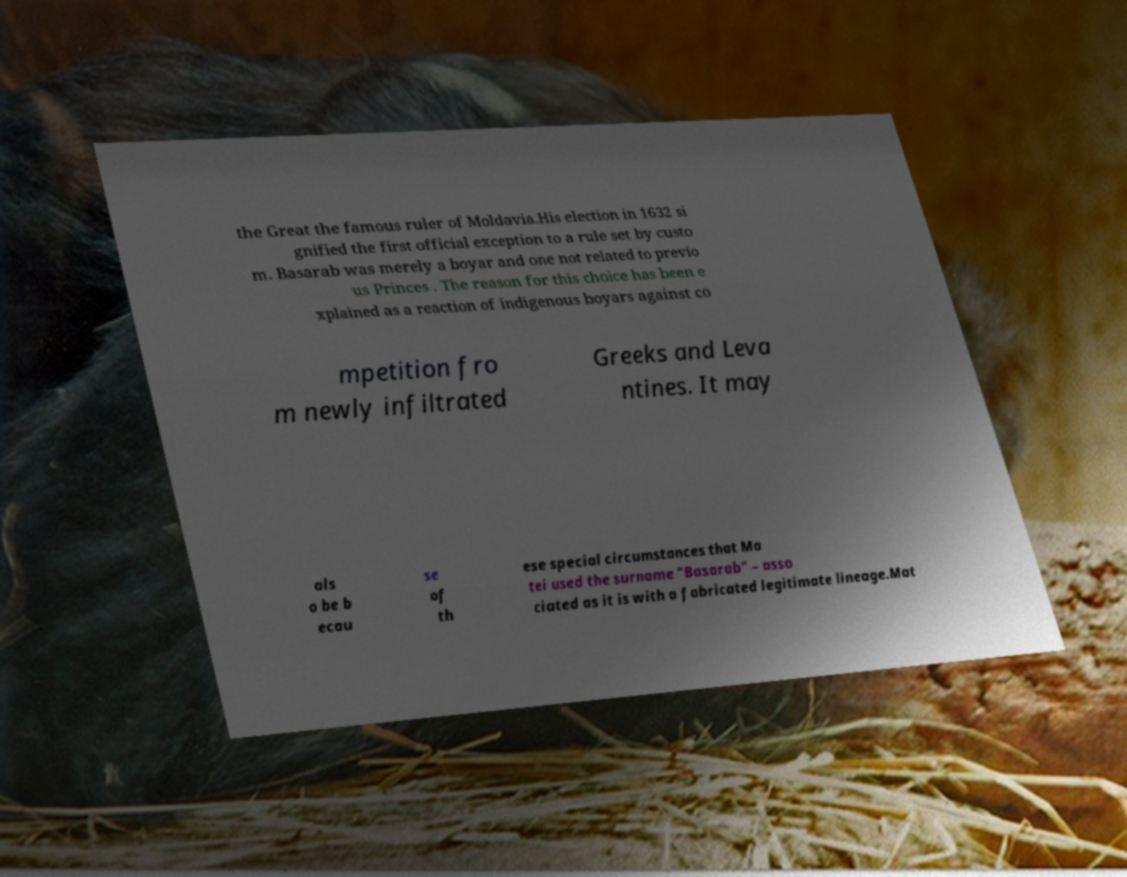Can you read and provide the text displayed in the image?This photo seems to have some interesting text. Can you extract and type it out for me? the Great the famous ruler of Moldavia.His election in 1632 si gnified the first official exception to a rule set by custo m. Basarab was merely a boyar and one not related to previo us Princes . The reason for this choice has been e xplained as a reaction of indigenous boyars against co mpetition fro m newly infiltrated Greeks and Leva ntines. It may als o be b ecau se of th ese special circumstances that Ma tei used the surname "Basarab" – asso ciated as it is with a fabricated legitimate lineage.Mat 